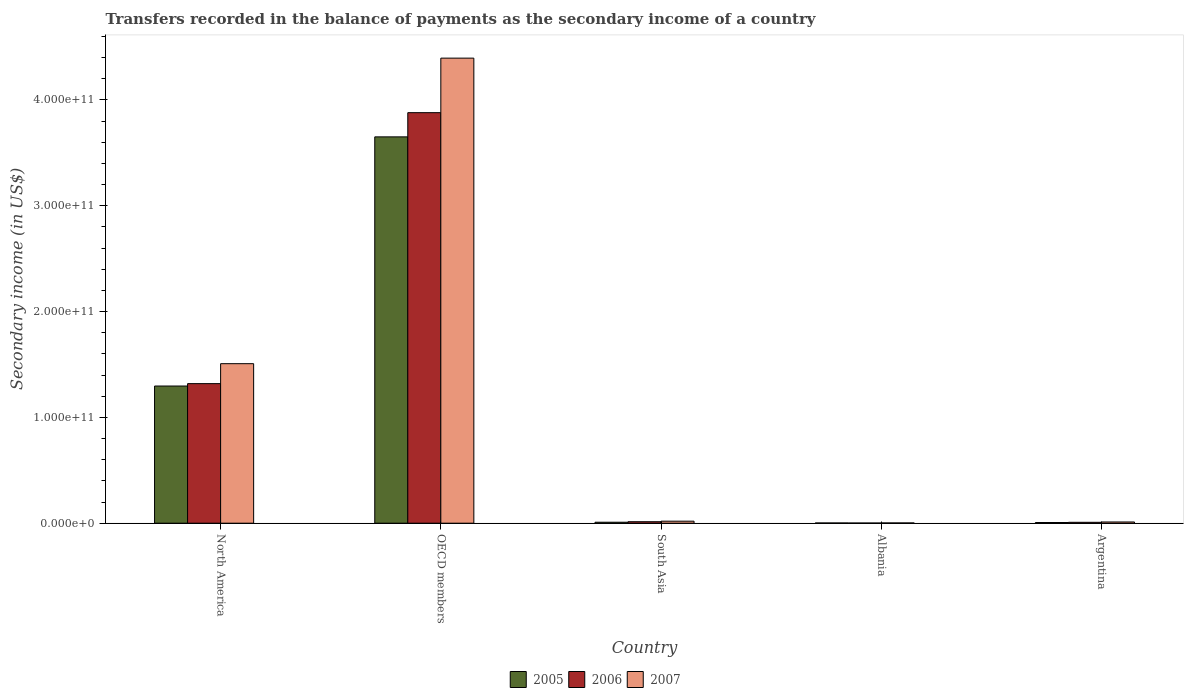How many groups of bars are there?
Your answer should be very brief. 5. Are the number of bars per tick equal to the number of legend labels?
Ensure brevity in your answer.  Yes. Are the number of bars on each tick of the X-axis equal?
Provide a succinct answer. Yes. In how many cases, is the number of bars for a given country not equal to the number of legend labels?
Provide a succinct answer. 0. What is the secondary income of in 2007 in North America?
Offer a very short reply. 1.51e+11. Across all countries, what is the maximum secondary income of in 2007?
Offer a very short reply. 4.39e+11. Across all countries, what is the minimum secondary income of in 2005?
Give a very brief answer. 2.20e+08. In which country was the secondary income of in 2005 maximum?
Make the answer very short. OECD members. In which country was the secondary income of in 2007 minimum?
Make the answer very short. Albania. What is the total secondary income of in 2005 in the graph?
Provide a succinct answer. 4.96e+11. What is the difference between the secondary income of in 2007 in Argentina and that in South Asia?
Your answer should be very brief. -7.49e+08. What is the difference between the secondary income of in 2007 in Albania and the secondary income of in 2005 in OECD members?
Your response must be concise. -3.65e+11. What is the average secondary income of in 2007 per country?
Provide a short and direct response. 1.19e+11. What is the difference between the secondary income of of/in 2006 and secondary income of of/in 2005 in North America?
Your answer should be very brief. 2.26e+09. In how many countries, is the secondary income of in 2007 greater than 280000000000 US$?
Your response must be concise. 1. What is the ratio of the secondary income of in 2007 in Albania to that in South Asia?
Make the answer very short. 0.13. Is the secondary income of in 2007 in North America less than that in OECD members?
Provide a short and direct response. Yes. Is the difference between the secondary income of in 2006 in OECD members and South Asia greater than the difference between the secondary income of in 2005 in OECD members and South Asia?
Provide a short and direct response. Yes. What is the difference between the highest and the second highest secondary income of in 2005?
Give a very brief answer. -3.64e+11. What is the difference between the highest and the lowest secondary income of in 2006?
Offer a terse response. 3.88e+11. Is the sum of the secondary income of in 2006 in Albania and Argentina greater than the maximum secondary income of in 2005 across all countries?
Your answer should be very brief. No. What does the 1st bar from the left in OECD members represents?
Ensure brevity in your answer.  2005. What does the 3rd bar from the right in Argentina represents?
Keep it short and to the point. 2005. Is it the case that in every country, the sum of the secondary income of in 2006 and secondary income of in 2005 is greater than the secondary income of in 2007?
Ensure brevity in your answer.  Yes. How many bars are there?
Ensure brevity in your answer.  15. What is the difference between two consecutive major ticks on the Y-axis?
Your answer should be compact. 1.00e+11. How many legend labels are there?
Your answer should be very brief. 3. How are the legend labels stacked?
Provide a succinct answer. Horizontal. What is the title of the graph?
Your answer should be very brief. Transfers recorded in the balance of payments as the secondary income of a country. Does "2010" appear as one of the legend labels in the graph?
Make the answer very short. No. What is the label or title of the X-axis?
Keep it short and to the point. Country. What is the label or title of the Y-axis?
Give a very brief answer. Secondary income (in US$). What is the Secondary income (in US$) in 2005 in North America?
Offer a very short reply. 1.30e+11. What is the Secondary income (in US$) in 2006 in North America?
Make the answer very short. 1.32e+11. What is the Secondary income (in US$) in 2007 in North America?
Your response must be concise. 1.51e+11. What is the Secondary income (in US$) of 2005 in OECD members?
Provide a short and direct response. 3.65e+11. What is the Secondary income (in US$) in 2006 in OECD members?
Your response must be concise. 3.88e+11. What is the Secondary income (in US$) of 2007 in OECD members?
Offer a very short reply. 4.39e+11. What is the Secondary income (in US$) in 2005 in South Asia?
Your response must be concise. 9.16e+08. What is the Secondary income (in US$) of 2006 in South Asia?
Offer a very short reply. 1.40e+09. What is the Secondary income (in US$) in 2007 in South Asia?
Make the answer very short. 1.90e+09. What is the Secondary income (in US$) in 2005 in Albania?
Keep it short and to the point. 2.20e+08. What is the Secondary income (in US$) in 2006 in Albania?
Offer a very short reply. 1.47e+08. What is the Secondary income (in US$) in 2007 in Albania?
Provide a short and direct response. 2.41e+08. What is the Secondary income (in US$) in 2005 in Argentina?
Your answer should be very brief. 6.58e+08. What is the Secondary income (in US$) of 2006 in Argentina?
Offer a terse response. 8.43e+08. What is the Secondary income (in US$) of 2007 in Argentina?
Ensure brevity in your answer.  1.16e+09. Across all countries, what is the maximum Secondary income (in US$) of 2005?
Provide a succinct answer. 3.65e+11. Across all countries, what is the maximum Secondary income (in US$) of 2006?
Your answer should be very brief. 3.88e+11. Across all countries, what is the maximum Secondary income (in US$) of 2007?
Make the answer very short. 4.39e+11. Across all countries, what is the minimum Secondary income (in US$) of 2005?
Offer a very short reply. 2.20e+08. Across all countries, what is the minimum Secondary income (in US$) in 2006?
Your answer should be compact. 1.47e+08. Across all countries, what is the minimum Secondary income (in US$) of 2007?
Your answer should be compact. 2.41e+08. What is the total Secondary income (in US$) in 2005 in the graph?
Your answer should be compact. 4.96e+11. What is the total Secondary income (in US$) of 2006 in the graph?
Your answer should be compact. 5.22e+11. What is the total Secondary income (in US$) in 2007 in the graph?
Offer a very short reply. 5.93e+11. What is the difference between the Secondary income (in US$) in 2005 in North America and that in OECD members?
Provide a succinct answer. -2.35e+11. What is the difference between the Secondary income (in US$) in 2006 in North America and that in OECD members?
Offer a very short reply. -2.56e+11. What is the difference between the Secondary income (in US$) in 2007 in North America and that in OECD members?
Make the answer very short. -2.89e+11. What is the difference between the Secondary income (in US$) in 2005 in North America and that in South Asia?
Make the answer very short. 1.29e+11. What is the difference between the Secondary income (in US$) in 2006 in North America and that in South Asia?
Your answer should be compact. 1.30e+11. What is the difference between the Secondary income (in US$) of 2007 in North America and that in South Asia?
Ensure brevity in your answer.  1.49e+11. What is the difference between the Secondary income (in US$) of 2005 in North America and that in Albania?
Provide a short and direct response. 1.29e+11. What is the difference between the Secondary income (in US$) of 2006 in North America and that in Albania?
Your response must be concise. 1.32e+11. What is the difference between the Secondary income (in US$) in 2007 in North America and that in Albania?
Make the answer very short. 1.50e+11. What is the difference between the Secondary income (in US$) in 2005 in North America and that in Argentina?
Your answer should be compact. 1.29e+11. What is the difference between the Secondary income (in US$) of 2006 in North America and that in Argentina?
Your answer should be very brief. 1.31e+11. What is the difference between the Secondary income (in US$) in 2007 in North America and that in Argentina?
Make the answer very short. 1.50e+11. What is the difference between the Secondary income (in US$) of 2005 in OECD members and that in South Asia?
Provide a succinct answer. 3.64e+11. What is the difference between the Secondary income (in US$) in 2006 in OECD members and that in South Asia?
Ensure brevity in your answer.  3.86e+11. What is the difference between the Secondary income (in US$) of 2007 in OECD members and that in South Asia?
Provide a succinct answer. 4.38e+11. What is the difference between the Secondary income (in US$) of 2005 in OECD members and that in Albania?
Your answer should be very brief. 3.65e+11. What is the difference between the Secondary income (in US$) of 2006 in OECD members and that in Albania?
Ensure brevity in your answer.  3.88e+11. What is the difference between the Secondary income (in US$) in 2007 in OECD members and that in Albania?
Give a very brief answer. 4.39e+11. What is the difference between the Secondary income (in US$) of 2005 in OECD members and that in Argentina?
Offer a terse response. 3.64e+11. What is the difference between the Secondary income (in US$) in 2006 in OECD members and that in Argentina?
Offer a terse response. 3.87e+11. What is the difference between the Secondary income (in US$) in 2007 in OECD members and that in Argentina?
Offer a terse response. 4.38e+11. What is the difference between the Secondary income (in US$) of 2005 in South Asia and that in Albania?
Offer a terse response. 6.96e+08. What is the difference between the Secondary income (in US$) in 2006 in South Asia and that in Albania?
Ensure brevity in your answer.  1.25e+09. What is the difference between the Secondary income (in US$) in 2007 in South Asia and that in Albania?
Keep it short and to the point. 1.66e+09. What is the difference between the Secondary income (in US$) of 2005 in South Asia and that in Argentina?
Offer a terse response. 2.59e+08. What is the difference between the Secondary income (in US$) of 2006 in South Asia and that in Argentina?
Provide a short and direct response. 5.52e+08. What is the difference between the Secondary income (in US$) of 2007 in South Asia and that in Argentina?
Ensure brevity in your answer.  7.49e+08. What is the difference between the Secondary income (in US$) of 2005 in Albania and that in Argentina?
Keep it short and to the point. -4.37e+08. What is the difference between the Secondary income (in US$) of 2006 in Albania and that in Argentina?
Your answer should be very brief. -6.95e+08. What is the difference between the Secondary income (in US$) of 2007 in Albania and that in Argentina?
Your answer should be very brief. -9.14e+08. What is the difference between the Secondary income (in US$) in 2005 in North America and the Secondary income (in US$) in 2006 in OECD members?
Keep it short and to the point. -2.58e+11. What is the difference between the Secondary income (in US$) of 2005 in North America and the Secondary income (in US$) of 2007 in OECD members?
Make the answer very short. -3.10e+11. What is the difference between the Secondary income (in US$) in 2006 in North America and the Secondary income (in US$) in 2007 in OECD members?
Your answer should be very brief. -3.08e+11. What is the difference between the Secondary income (in US$) of 2005 in North America and the Secondary income (in US$) of 2006 in South Asia?
Ensure brevity in your answer.  1.28e+11. What is the difference between the Secondary income (in US$) in 2005 in North America and the Secondary income (in US$) in 2007 in South Asia?
Your response must be concise. 1.28e+11. What is the difference between the Secondary income (in US$) in 2006 in North America and the Secondary income (in US$) in 2007 in South Asia?
Make the answer very short. 1.30e+11. What is the difference between the Secondary income (in US$) in 2005 in North America and the Secondary income (in US$) in 2006 in Albania?
Ensure brevity in your answer.  1.29e+11. What is the difference between the Secondary income (in US$) of 2005 in North America and the Secondary income (in US$) of 2007 in Albania?
Your answer should be very brief. 1.29e+11. What is the difference between the Secondary income (in US$) in 2006 in North America and the Secondary income (in US$) in 2007 in Albania?
Your answer should be compact. 1.32e+11. What is the difference between the Secondary income (in US$) of 2005 in North America and the Secondary income (in US$) of 2006 in Argentina?
Your answer should be very brief. 1.29e+11. What is the difference between the Secondary income (in US$) of 2005 in North America and the Secondary income (in US$) of 2007 in Argentina?
Make the answer very short. 1.28e+11. What is the difference between the Secondary income (in US$) of 2006 in North America and the Secondary income (in US$) of 2007 in Argentina?
Your response must be concise. 1.31e+11. What is the difference between the Secondary income (in US$) in 2005 in OECD members and the Secondary income (in US$) in 2006 in South Asia?
Provide a succinct answer. 3.64e+11. What is the difference between the Secondary income (in US$) in 2005 in OECD members and the Secondary income (in US$) in 2007 in South Asia?
Make the answer very short. 3.63e+11. What is the difference between the Secondary income (in US$) of 2006 in OECD members and the Secondary income (in US$) of 2007 in South Asia?
Your answer should be very brief. 3.86e+11. What is the difference between the Secondary income (in US$) of 2005 in OECD members and the Secondary income (in US$) of 2006 in Albania?
Your answer should be compact. 3.65e+11. What is the difference between the Secondary income (in US$) of 2005 in OECD members and the Secondary income (in US$) of 2007 in Albania?
Your answer should be compact. 3.65e+11. What is the difference between the Secondary income (in US$) in 2006 in OECD members and the Secondary income (in US$) in 2007 in Albania?
Ensure brevity in your answer.  3.88e+11. What is the difference between the Secondary income (in US$) in 2005 in OECD members and the Secondary income (in US$) in 2006 in Argentina?
Ensure brevity in your answer.  3.64e+11. What is the difference between the Secondary income (in US$) of 2005 in OECD members and the Secondary income (in US$) of 2007 in Argentina?
Provide a short and direct response. 3.64e+11. What is the difference between the Secondary income (in US$) of 2006 in OECD members and the Secondary income (in US$) of 2007 in Argentina?
Give a very brief answer. 3.87e+11. What is the difference between the Secondary income (in US$) in 2005 in South Asia and the Secondary income (in US$) in 2006 in Albania?
Your answer should be very brief. 7.69e+08. What is the difference between the Secondary income (in US$) of 2005 in South Asia and the Secondary income (in US$) of 2007 in Albania?
Offer a very short reply. 6.75e+08. What is the difference between the Secondary income (in US$) of 2006 in South Asia and the Secondary income (in US$) of 2007 in Albania?
Your response must be concise. 1.15e+09. What is the difference between the Secondary income (in US$) in 2005 in South Asia and the Secondary income (in US$) in 2006 in Argentina?
Your answer should be very brief. 7.37e+07. What is the difference between the Secondary income (in US$) of 2005 in South Asia and the Secondary income (in US$) of 2007 in Argentina?
Provide a succinct answer. -2.40e+08. What is the difference between the Secondary income (in US$) in 2006 in South Asia and the Secondary income (in US$) in 2007 in Argentina?
Make the answer very short. 2.39e+08. What is the difference between the Secondary income (in US$) in 2005 in Albania and the Secondary income (in US$) in 2006 in Argentina?
Ensure brevity in your answer.  -6.22e+08. What is the difference between the Secondary income (in US$) in 2005 in Albania and the Secondary income (in US$) in 2007 in Argentina?
Offer a very short reply. -9.35e+08. What is the difference between the Secondary income (in US$) in 2006 in Albania and the Secondary income (in US$) in 2007 in Argentina?
Offer a very short reply. -1.01e+09. What is the average Secondary income (in US$) in 2005 per country?
Provide a short and direct response. 9.93e+1. What is the average Secondary income (in US$) in 2006 per country?
Your answer should be compact. 1.04e+11. What is the average Secondary income (in US$) of 2007 per country?
Offer a very short reply. 1.19e+11. What is the difference between the Secondary income (in US$) in 2005 and Secondary income (in US$) in 2006 in North America?
Keep it short and to the point. -2.26e+09. What is the difference between the Secondary income (in US$) of 2005 and Secondary income (in US$) of 2007 in North America?
Make the answer very short. -2.11e+1. What is the difference between the Secondary income (in US$) in 2006 and Secondary income (in US$) in 2007 in North America?
Your answer should be very brief. -1.89e+1. What is the difference between the Secondary income (in US$) in 2005 and Secondary income (in US$) in 2006 in OECD members?
Your answer should be compact. -2.29e+1. What is the difference between the Secondary income (in US$) of 2005 and Secondary income (in US$) of 2007 in OECD members?
Provide a short and direct response. -7.44e+1. What is the difference between the Secondary income (in US$) of 2006 and Secondary income (in US$) of 2007 in OECD members?
Provide a succinct answer. -5.15e+1. What is the difference between the Secondary income (in US$) in 2005 and Secondary income (in US$) in 2006 in South Asia?
Offer a terse response. -4.79e+08. What is the difference between the Secondary income (in US$) of 2005 and Secondary income (in US$) of 2007 in South Asia?
Offer a terse response. -9.88e+08. What is the difference between the Secondary income (in US$) of 2006 and Secondary income (in US$) of 2007 in South Asia?
Ensure brevity in your answer.  -5.09e+08. What is the difference between the Secondary income (in US$) in 2005 and Secondary income (in US$) in 2006 in Albania?
Keep it short and to the point. 7.32e+07. What is the difference between the Secondary income (in US$) of 2005 and Secondary income (in US$) of 2007 in Albania?
Your response must be concise. -2.09e+07. What is the difference between the Secondary income (in US$) in 2006 and Secondary income (in US$) in 2007 in Albania?
Make the answer very short. -9.41e+07. What is the difference between the Secondary income (in US$) in 2005 and Secondary income (in US$) in 2006 in Argentina?
Ensure brevity in your answer.  -1.85e+08. What is the difference between the Secondary income (in US$) of 2005 and Secondary income (in US$) of 2007 in Argentina?
Offer a very short reply. -4.98e+08. What is the difference between the Secondary income (in US$) in 2006 and Secondary income (in US$) in 2007 in Argentina?
Offer a very short reply. -3.13e+08. What is the ratio of the Secondary income (in US$) in 2005 in North America to that in OECD members?
Make the answer very short. 0.36. What is the ratio of the Secondary income (in US$) of 2006 in North America to that in OECD members?
Provide a short and direct response. 0.34. What is the ratio of the Secondary income (in US$) of 2007 in North America to that in OECD members?
Offer a very short reply. 0.34. What is the ratio of the Secondary income (in US$) of 2005 in North America to that in South Asia?
Give a very brief answer. 141.45. What is the ratio of the Secondary income (in US$) of 2006 in North America to that in South Asia?
Your response must be concise. 94.53. What is the ratio of the Secondary income (in US$) of 2007 in North America to that in South Asia?
Ensure brevity in your answer.  79.14. What is the ratio of the Secondary income (in US$) in 2005 in North America to that in Albania?
Provide a succinct answer. 587.93. What is the ratio of the Secondary income (in US$) of 2006 in North America to that in Albania?
Ensure brevity in your answer.  895.54. What is the ratio of the Secondary income (in US$) in 2007 in North America to that in Albania?
Your answer should be very brief. 624.46. What is the ratio of the Secondary income (in US$) of 2005 in North America to that in Argentina?
Provide a short and direct response. 197.03. What is the ratio of the Secondary income (in US$) of 2006 in North America to that in Argentina?
Offer a terse response. 156.51. What is the ratio of the Secondary income (in US$) in 2007 in North America to that in Argentina?
Offer a very short reply. 130.4. What is the ratio of the Secondary income (in US$) in 2005 in OECD members to that in South Asia?
Provide a short and direct response. 398.35. What is the ratio of the Secondary income (in US$) of 2006 in OECD members to that in South Asia?
Keep it short and to the point. 278.04. What is the ratio of the Secondary income (in US$) in 2007 in OECD members to that in South Asia?
Offer a terse response. 230.72. What is the ratio of the Secondary income (in US$) of 2005 in OECD members to that in Albania?
Keep it short and to the point. 1655.77. What is the ratio of the Secondary income (in US$) of 2006 in OECD members to that in Albania?
Provide a succinct answer. 2634.16. What is the ratio of the Secondary income (in US$) of 2007 in OECD members to that in Albania?
Your answer should be compact. 1820.54. What is the ratio of the Secondary income (in US$) of 2005 in OECD members to that in Argentina?
Your response must be concise. 554.9. What is the ratio of the Secondary income (in US$) of 2006 in OECD members to that in Argentina?
Keep it short and to the point. 460.35. What is the ratio of the Secondary income (in US$) in 2007 in OECD members to that in Argentina?
Provide a short and direct response. 380.17. What is the ratio of the Secondary income (in US$) of 2005 in South Asia to that in Albania?
Make the answer very short. 4.16. What is the ratio of the Secondary income (in US$) in 2006 in South Asia to that in Albania?
Provide a succinct answer. 9.47. What is the ratio of the Secondary income (in US$) in 2007 in South Asia to that in Albania?
Offer a very short reply. 7.89. What is the ratio of the Secondary income (in US$) of 2005 in South Asia to that in Argentina?
Make the answer very short. 1.39. What is the ratio of the Secondary income (in US$) in 2006 in South Asia to that in Argentina?
Your response must be concise. 1.66. What is the ratio of the Secondary income (in US$) in 2007 in South Asia to that in Argentina?
Make the answer very short. 1.65. What is the ratio of the Secondary income (in US$) of 2005 in Albania to that in Argentina?
Provide a succinct answer. 0.34. What is the ratio of the Secondary income (in US$) of 2006 in Albania to that in Argentina?
Your answer should be very brief. 0.17. What is the ratio of the Secondary income (in US$) in 2007 in Albania to that in Argentina?
Provide a short and direct response. 0.21. What is the difference between the highest and the second highest Secondary income (in US$) in 2005?
Your answer should be very brief. 2.35e+11. What is the difference between the highest and the second highest Secondary income (in US$) of 2006?
Your answer should be compact. 2.56e+11. What is the difference between the highest and the second highest Secondary income (in US$) of 2007?
Keep it short and to the point. 2.89e+11. What is the difference between the highest and the lowest Secondary income (in US$) in 2005?
Make the answer very short. 3.65e+11. What is the difference between the highest and the lowest Secondary income (in US$) of 2006?
Keep it short and to the point. 3.88e+11. What is the difference between the highest and the lowest Secondary income (in US$) of 2007?
Provide a short and direct response. 4.39e+11. 